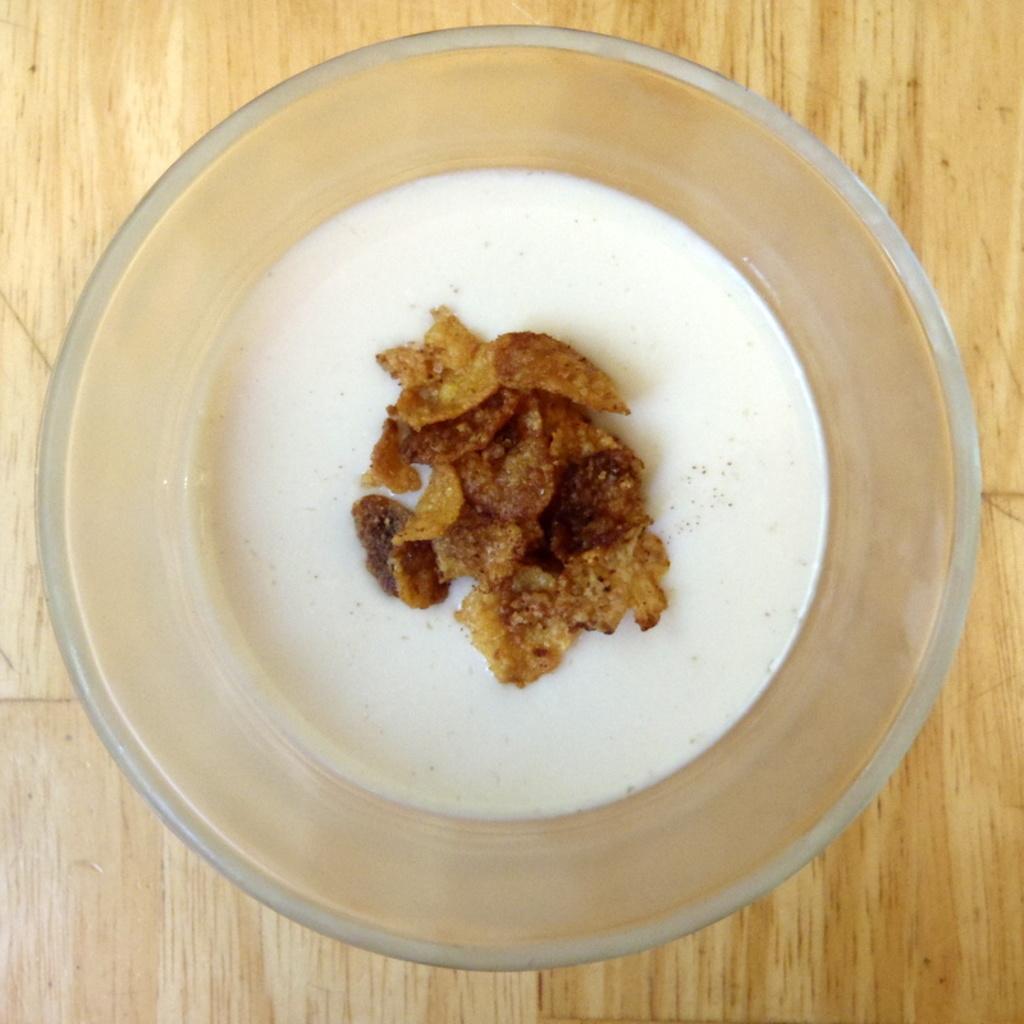Please provide a concise description of this image. In this image I can see a bowl and on the bowl I can see a food and the bowl is kept on the table. 